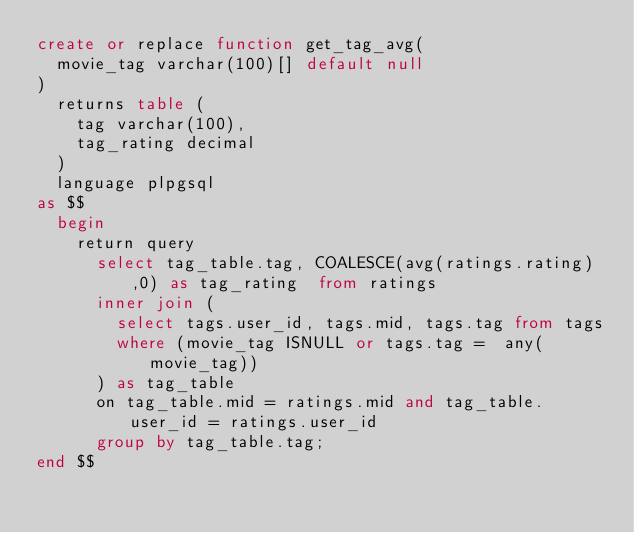Convert code to text. <code><loc_0><loc_0><loc_500><loc_500><_SQL_>create or replace function get_tag_avg(
	movie_tag varchar(100)[] default null
) 
	returns table (
		tag varchar(100),
		tag_rating decimal
	)
	language plpgsql
as $$
	begin 
		return query 
			select tag_table.tag, COALESCE(avg(ratings.rating),0) as tag_rating  from ratings 
			inner join (
				select tags.user_id, tags.mid, tags.tag from tags 
				where (movie_tag ISNULL or tags.tag =  any(movie_tag))
			) as tag_table
			on tag_table.mid = ratings.mid and tag_table.user_id = ratings.user_id
			group by tag_table.tag;
end $$</code> 